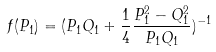<formula> <loc_0><loc_0><loc_500><loc_500>f ( P _ { 1 } ) = ( P _ { 1 } Q _ { 1 } + \frac { 1 } { 4 } \frac { P _ { 1 } ^ { 2 } - Q _ { 1 } ^ { 2 } } { P _ { 1 } Q _ { 1 } } ) ^ { - 1 }</formula> 